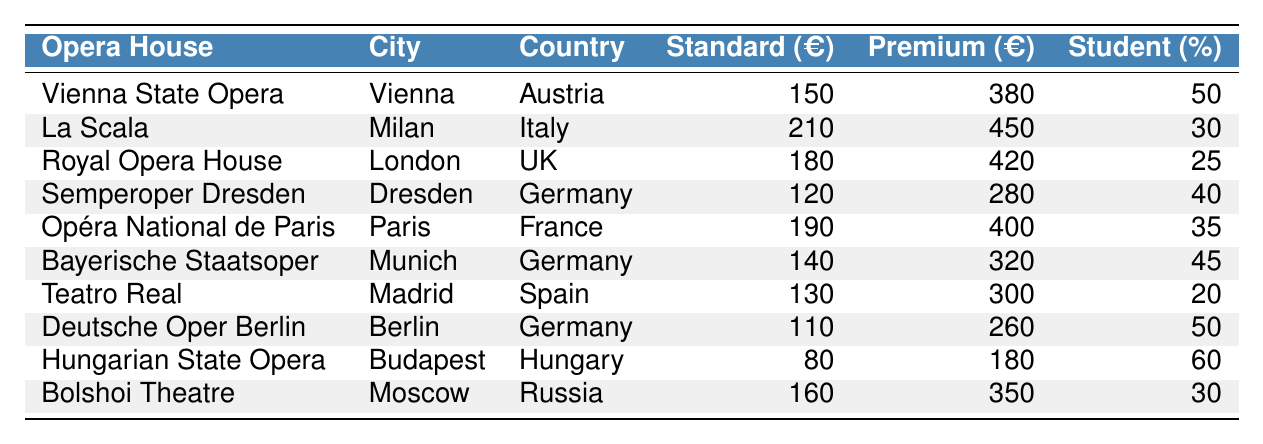What is the standard ticket price at the Vienna State Opera? The standard ticket price for the Vienna State Opera is listed directly in the table under "Standard Ticket Price (€)", which shows €150.
Answer: €150 What city is La Scala located in? La Scala is identified in the table, and it is located in Milan, as mentioned in the corresponding row.
Answer: Milan Which opera house has the highest premium ticket price? By looking at the "Premium Ticket Price (€)" column, La Scala shows the highest premium ticket price of €450 compared to other opera houses.
Answer: La Scala What is the student discount percentage at the Deutsche Oper Berlin? The table specifically lists the student discount for Deutsche Oper Berlin under the "Student Discount (%)" column, which shows 50%.
Answer: 50% How much more is the premium ticket at La Scala compared to the premium ticket at the Semperoper Dresden? The premium ticket price at La Scala is €450 and at the Semperoper Dresden is €280. The difference is €450 - €280 = €170.
Answer: €170 What is the average standard ticket price among all listed opera houses? To find the average, sum all standard ticket prices (€150 + €210 + €180 + €120 + €190 + €140 + €130 + €110 + €80 + €160) = €1,370, and divide by the number of opera houses (10). The average is €1,370 / 10 = €137.
Answer: €137 Is the student discount at the Bolshoi Theatre higher than that at the Royal Opera House? The Bolshoi Theatre has a student discount of 30% as per the table, while the Royal Opera House has a student discount of 25%. Since 30% > 25%, the answer is yes.
Answer: Yes Which opera house offers the lowest standard ticket price? By scanning the "Standard Ticket Price (€)" column, the lowest price is €80, which corresponds to the Hungarian State Opera.
Answer: Hungarian State Opera If a student wants to buy a premium ticket for the Bayerische Staatsoper, what is the price after applying the student discount? The premium price is €320 and the student discount is 45%. The amount discounted is €320 * 0.45 = €144. Therefore, the final price is €320 - €144 = €176.
Answer: €176 Which country has the most opera houses listed in this table? By checking the table, Germany is represented three times with Semperoper Dresden, Bayerische Staatsoper, and Deutsche Oper Berlin, making it the country with the most entries.
Answer: Germany What is the difference in the standard ticket price between the Hungarian State Opera and the Royal Opera House? The standard ticket price for the Hungarian State Opera is €80 and for the Royal Opera House is €180. The difference is €180 - €80 = €100.
Answer: €100 